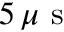<formula> <loc_0><loc_0><loc_500><loc_500>5 \, \mu s</formula> 